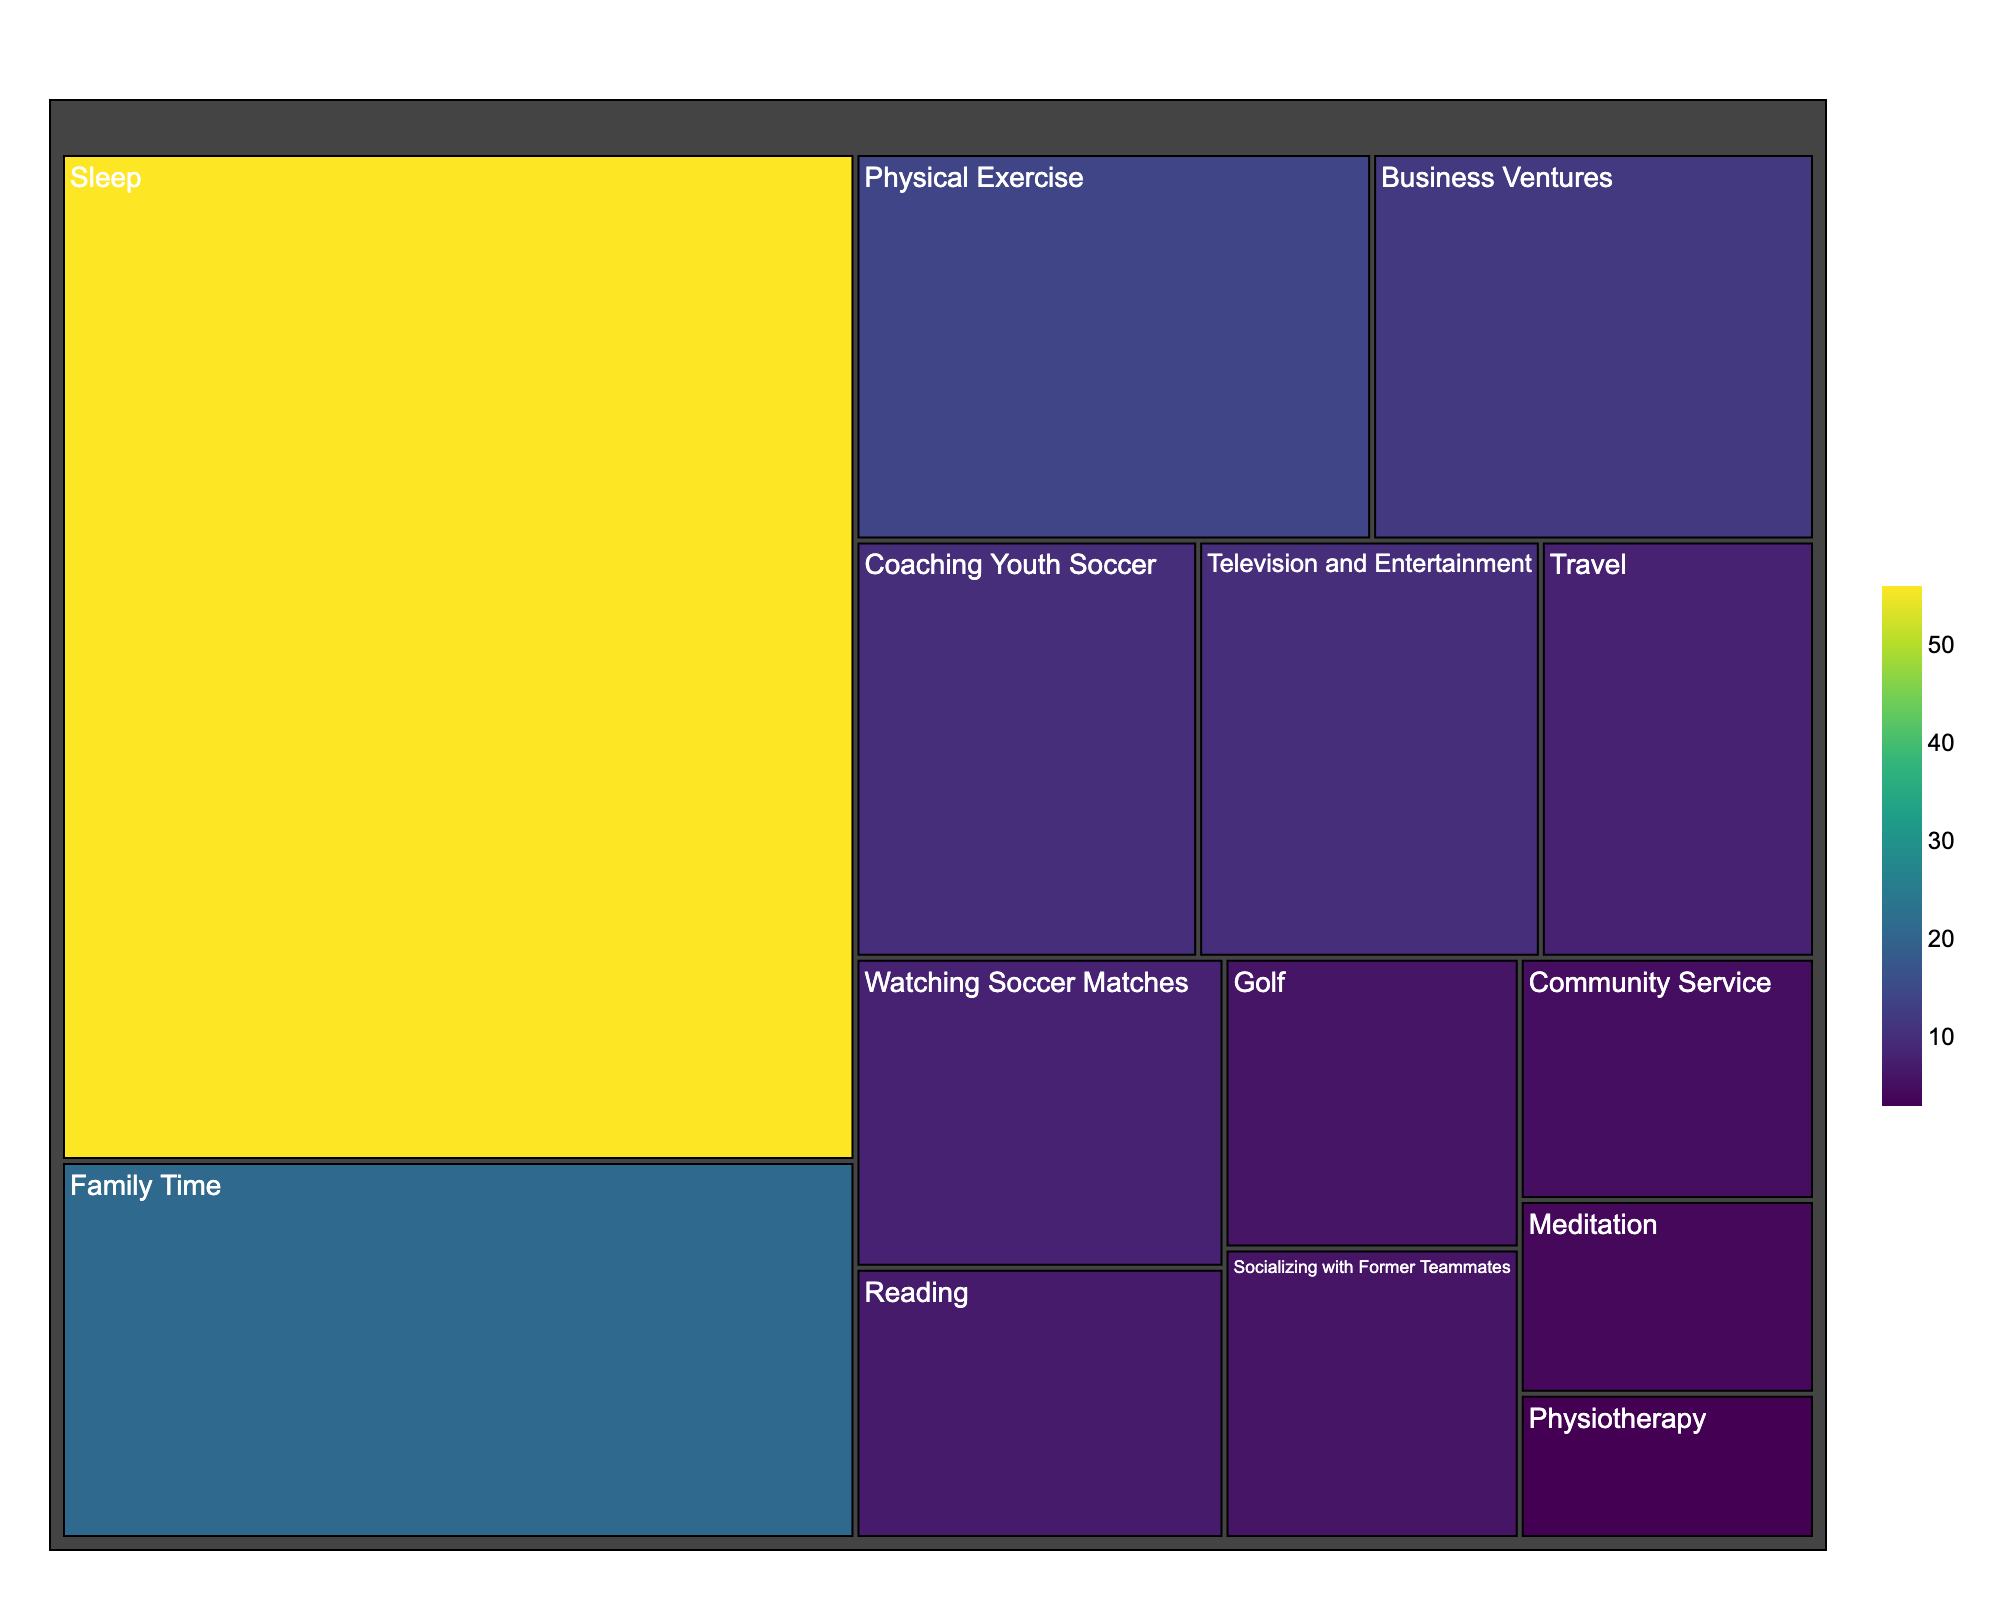What activity is allocated the most hours? The plot shows the allocation of time with the size of each rectangle representing the number of hours. By observing the figure, we see that "Sleep" has the largest rectangle, indicating the highest allocation of hours.
Answer: Sleep How many hours are spent on Business Ventures? In the figure, locate the rectangle labeled "Business Ventures." The hours spent are displayed within or on hover.
Answer: 12 Which activity has the fewest hours allocated? By looking at the smallest rectangle in the treemap, which represents the smallest time allocation. "Physiotherapy" has the smallest rectangle.
Answer: Physiotherapy What is the sum of hours spent on Sleep, Physical Exercise, and Family Time? Add the hours for "Sleep" (56), "Physical Exercise" (14), and "Family Time" (21). The sum is 56 + 14 + 21.
Answer: 91 Does Socializing with Former Teammates take more time than Watching Soccer Matches? Compare the rectangles for "Socializing with Former Teammates" (6 hours) and "Watching Soccer Matches" (8 hours). The latter is larger in size and value.
Answer: No How many more hours are allocated to Coaching Youth Soccer compared to Community Service? Subtract the hours for "Community Service" (5) from "Coaching Youth Soccer" (10). The difference is 10 - 5.
Answer: 5 Which two activities have been allocated equal hours? By scanning the treemap, we identify that both "Socializing with Former Teammates" and "Golf" have 6 hours each.
Answer: Socializing with Former Teammates and Golf How much time in total is allocated to Meditation and Physiotherapy? Add the hours for "Meditation" (4) and "Physiotherapy" (3). The sum is 4 + 3.
Answer: 7 What percentage of the total hours is spent on Television and Entertainment? Calculate the total hours (sum of all activities) and then find the fraction of hours allocated to "Television and Entertainment" (10). Total hours = 170. Percentage is (10/170) * 100.
Answer: ~5.88% How many activities have more than 10 hours allocated? Count the rectangles where the number of hours is greater than 10. There are three such activities: Sleep, Family Time, Business Ventures.
Answer: 3 